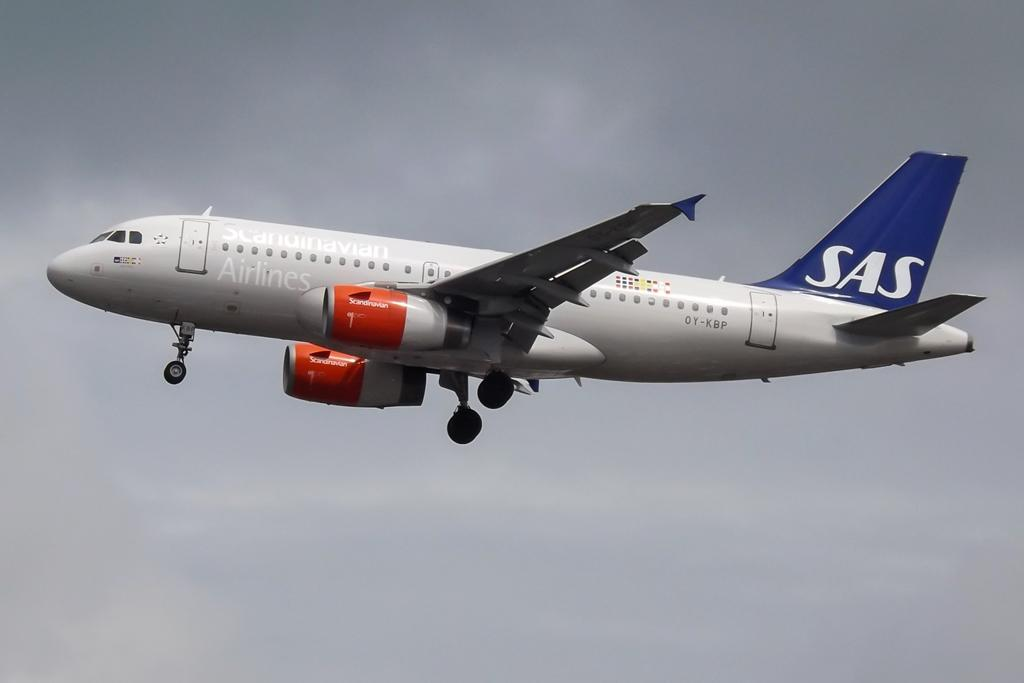Provide a one-sentence caption for the provided image. Scandinavian Airlines with a white SAS on the wing on a airplane. 